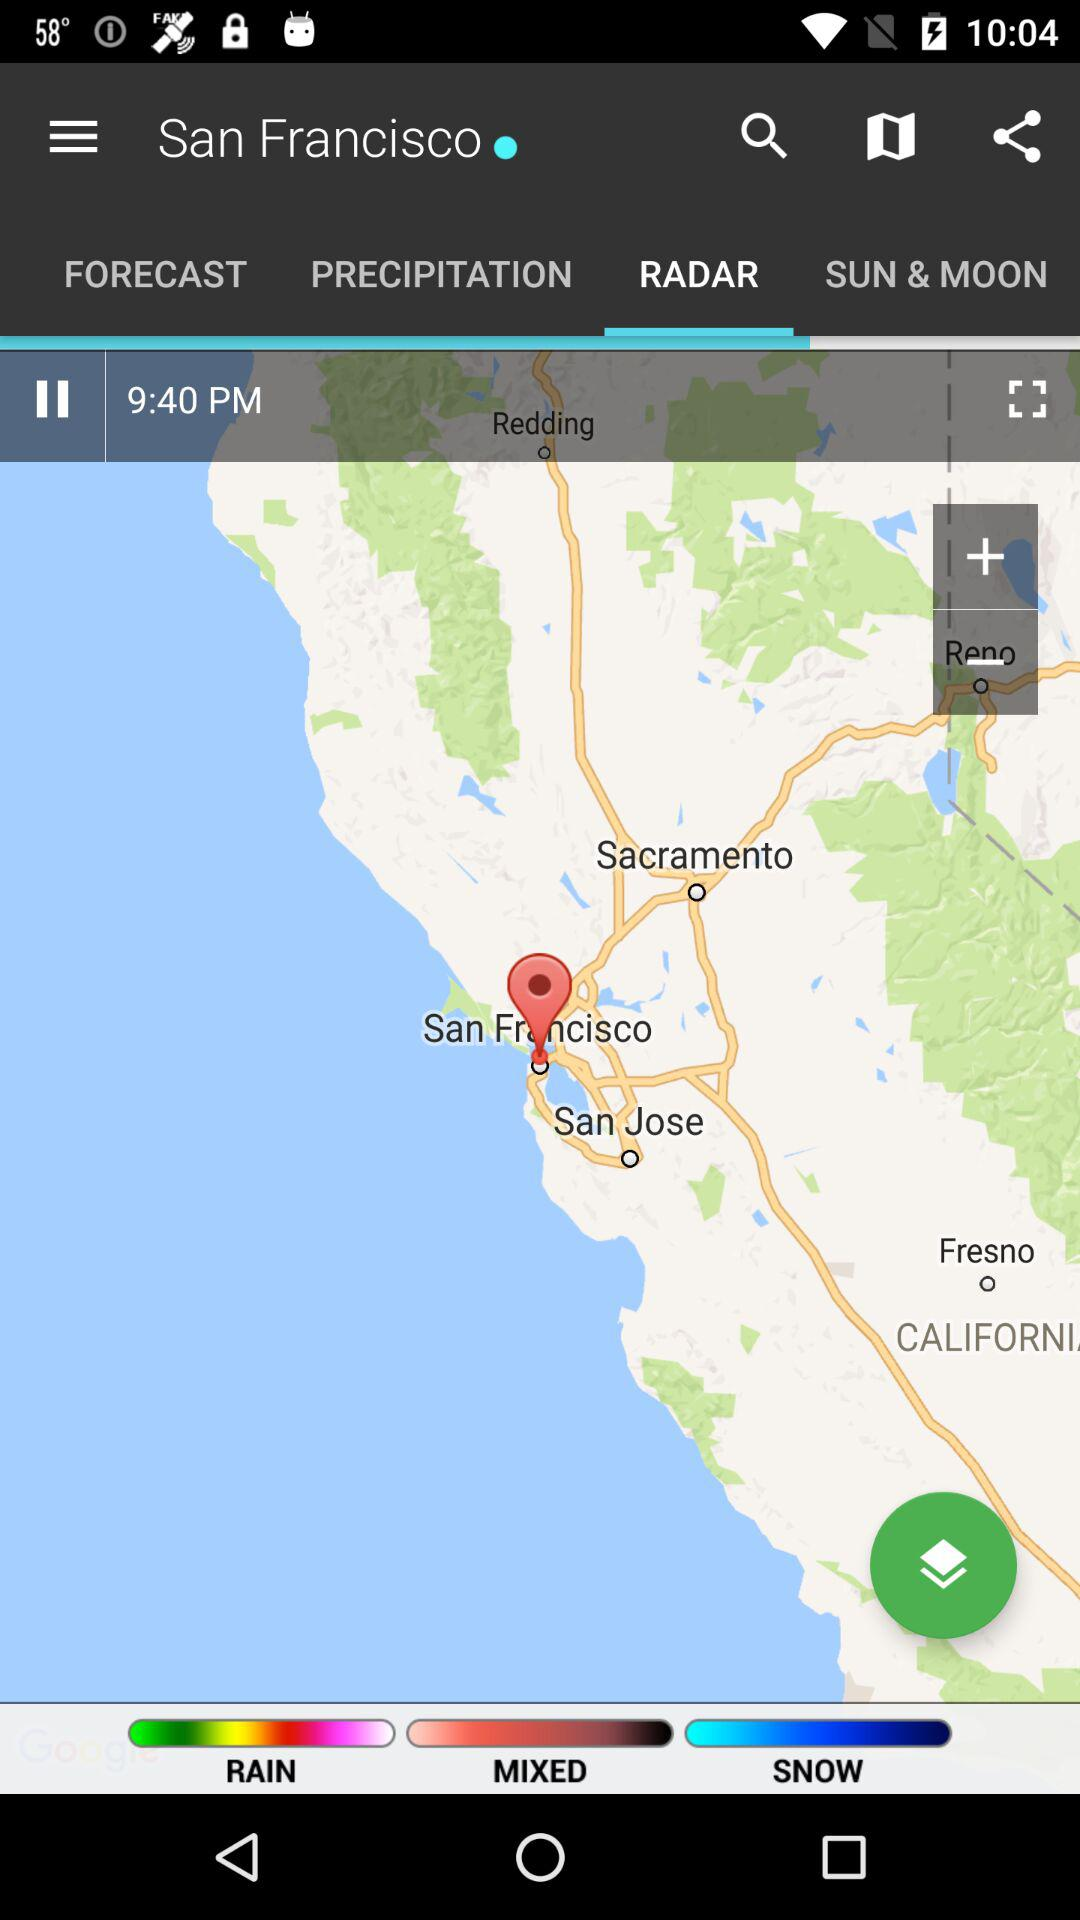How many weather conditions are there?
Answer the question using a single word or phrase. 3 